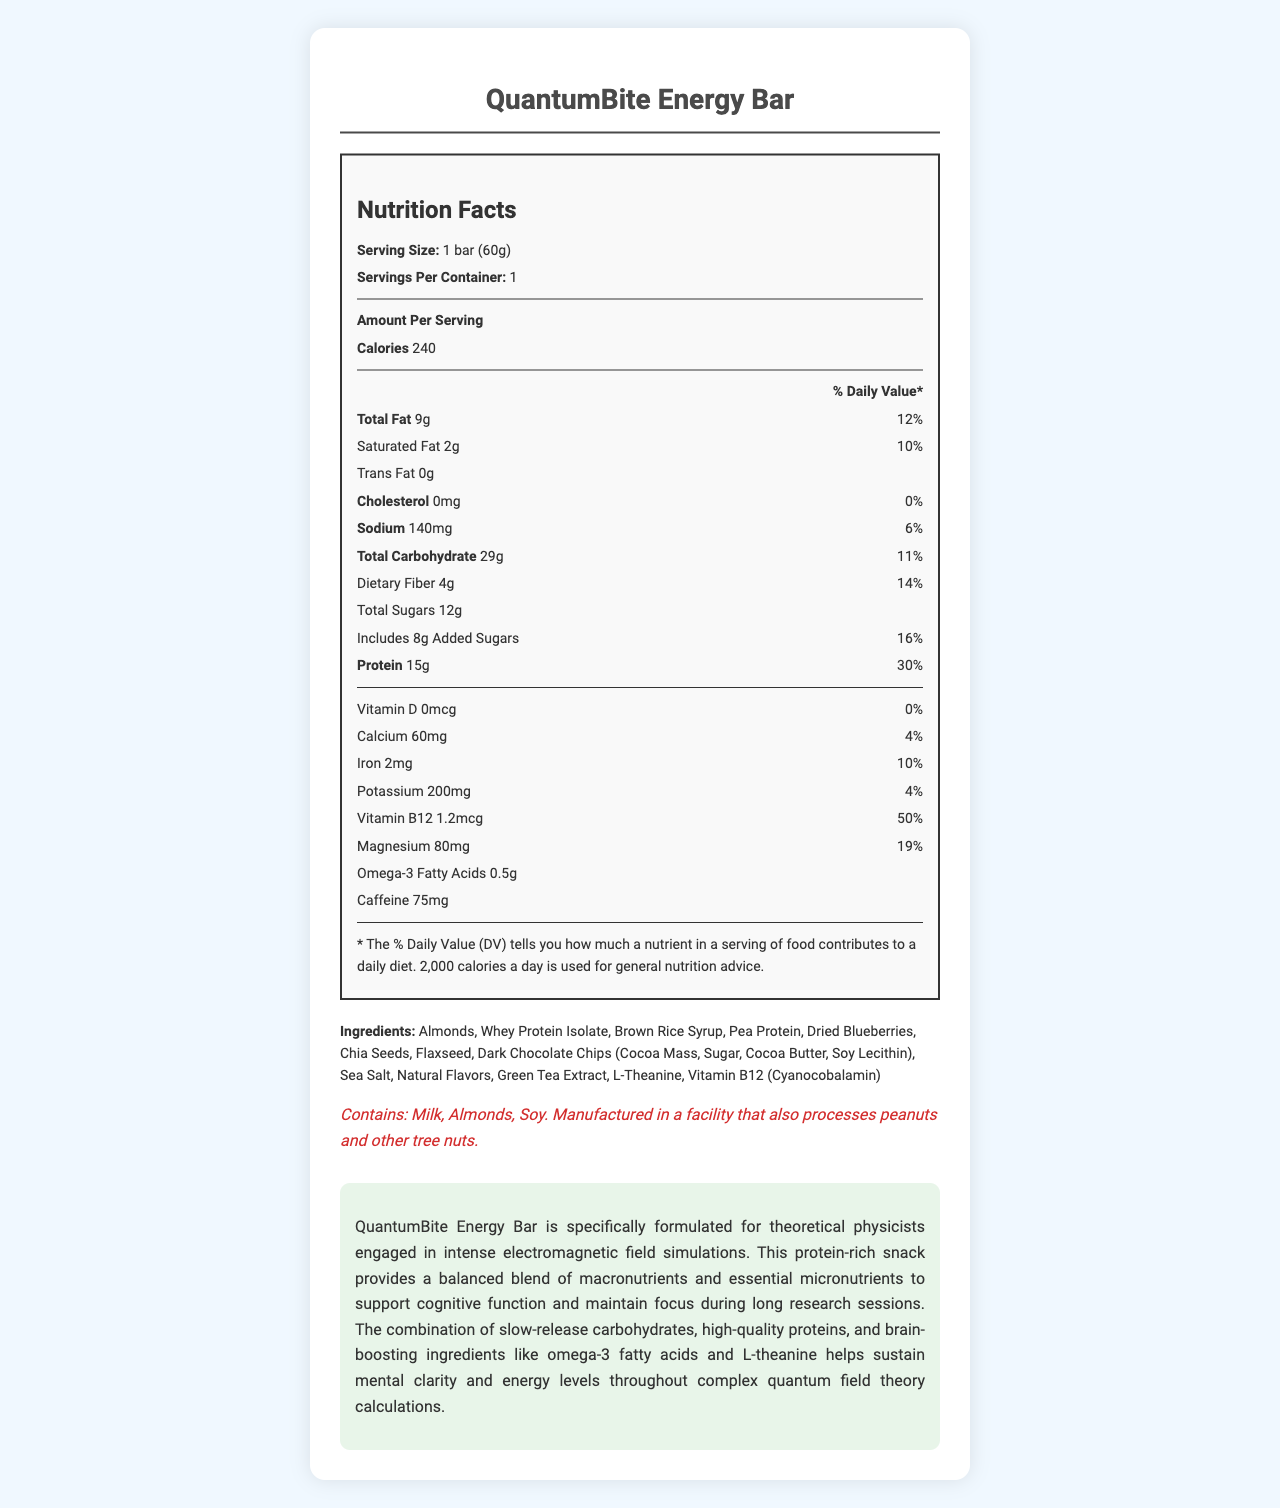what is the serving size of QuantumBite Energy Bar? The Nutrition Facts section of the document states that the serving size is "1 bar (60g)".
Answer: 1 bar (60g) how much dietary fiber does one bar contain? The Nutrition Facts section lists dietary fiber as 4g per serving, which is one bar.
Answer: 4g what percentage of daily Vitamin B12 is provided by one bar? The Vitamin B12 amount is 1.2mcg, which corresponds to 50% of the daily value, as noted in the Nutrition Facts.
Answer: 50% how many grams of protein are in one serving? The document specifies 15g of protein per serving, which is one bar.
Answer: 15g which of the following vitamins and minerals are NOT included in the QuantumBite Energy Bar? A. Vitamin D B. Calcium C. Vitamin C D. Iron The listed vitamins and minerals are Vitamin D, Calcium, Iron, Potassium, Vitamin B12, and Magnesium. Vitamin C is not mentioned.
Answer: C. Vitamin C how does the total fat content of the bar compare to daily recommended values? The document mentions that the total fat content is 9g, which is equivalent to 12% of the daily recommended value.
Answer: 12% is the QuantumBite Energy Bar suitable for someone with a nut allergy? The allergen information indicates that the bar contains Almonds and is processed in a facility that handles other tree nuts, making it unsuitable for someone with a nut allergy.
Answer: No what are the main sources of protein in the ingredients? The ingredients section lists Whey Protein Isolate and Pea Protein, both of which are known protein sources.
Answer: Whey Protein Isolate, Pea Protein are there any artificial flavors in the bar? The ingredients only mention "Natural Flavors" and do not refer to any artificial flavors.
Answer: No how might the caffeine content affect someone during simulation work? The bar contains 75mg of caffeine, which can help improve alertness and cognitive function, beneficial during intensive tasks like electromagnetic field simulations.
Answer: It could help maintain focus and alertness what types of carbohydrates are included in the bar? A. Simple Carbohydrates B. Complex Carbohydrates C. Both The ingredients list includes Brown Rice Syrup (simple carbohydrates) and whole ingredients like Dried Blueberries and whole seeds which contribute to complex carbohydrates.
Answer: C. Both does the product contain any trans fat? The Nutrition Facts section indicates that the trans fat content is 0g.
Answer: No summarize the main points of the document. The document highlights the QuantumBite Energy Bar's nutritional composition, usage, and benefits, providing a comprehensive overview of its nutritional value, ingredients, and suitability for sustaining mental clarity.
Answer: The document provides the nutritional information for the QuantumBite Energy Bar, emphasizing its balanced blend of macronutrients and essential micronutrients designed to support cognitive function and maintain focus during long research sessions. It also details the ingredients, allergen information, and specific nutrients that cater to the needs of theoretical physicists engaged in intense simulations. How many different types of nuts are explicitly mentioned in the ingredients? The only nut explicitly mentioned in the ingredients is Almonds.
Answer: One how many servings are in one container? The document states that there is 1 serving per container.
Answer: 1 what is the exact amount of vitamin D present in the bar? The amount of vitamin D listed in the Nutrition Facts is 0mcg.
Answer: 0mcg what is the total percentage of daily value for magnesium in one bar? The document specifies that the bar provides 19% of the daily value of magnesium.
Answer: 19% does the product help boost brain function according to the description? The description states that the bar includes brain-boosting ingredients like omega-3 fatty acids and L-theanine to help sustain mental clarity and energy.
Answer: Yes is the sodium content in the bar relatively high? The sodium content is 140mg, which is 6% of the daily value, not particularly high.
Answer: No what is the main idea behind the QuantumBite Energy Bar? The QuantumBite Energy Bar combines macronutrients and essential micronutrients, specially formulated to support mental clarity and energy levels, making it suitable for sustaining focus during complex tasks.
Answer: The main idea is to provide a balanced, protein-rich snack designed to help theoretical physicists maintain focus and cognitive function during intense research activities. what is the calorie content per serving? The Nutrition Facts section states that there are 240 calories per serving.
Answer: 240 what's the amount of added sugars per bar, and what is its percentage of daily value? The document indicates that the bar contains 8g of added sugars, which is 16% of the daily value.
Answer: 8g, 16% does the bar include any ingredients that aid in relaxation? The ingredients list includes L-Theanine, known to aid relaxation and reduce stress, complementing the bar's focus-enhancing properties.
Answer: Yes 